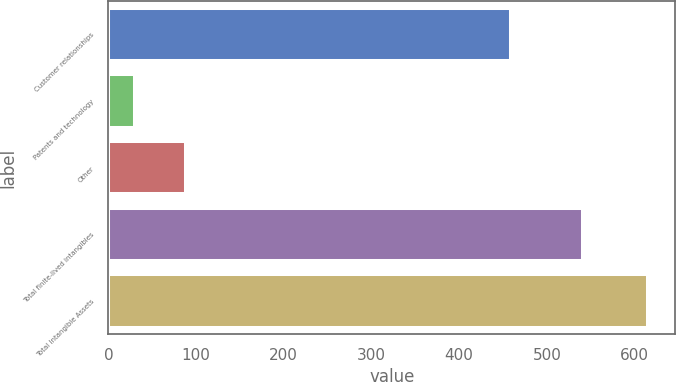<chart> <loc_0><loc_0><loc_500><loc_500><bar_chart><fcel>Customer relationships<fcel>Patents and technology<fcel>Other<fcel>Total finite-lived intangibles<fcel>Total Intangible Assets<nl><fcel>458.8<fcel>30.2<fcel>88.76<fcel>541.2<fcel>615.8<nl></chart> 